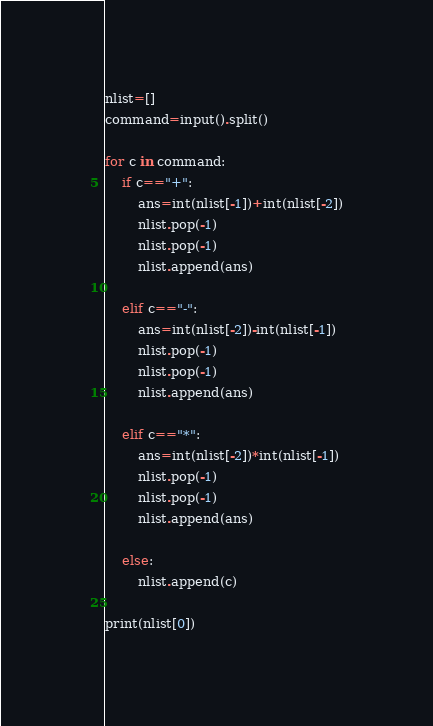<code> <loc_0><loc_0><loc_500><loc_500><_Python_>nlist=[]
command=input().split()

for c in command:
    if c=="+":
        ans=int(nlist[-1])+int(nlist[-2])
        nlist.pop(-1)
        nlist.pop(-1)
        nlist.append(ans)

    elif c=="-":
        ans=int(nlist[-2])-int(nlist[-1])
        nlist.pop(-1)
        nlist.pop(-1)
        nlist.append(ans)

    elif c=="*":
        ans=int(nlist[-2])*int(nlist[-1])
        nlist.pop(-1)
        nlist.pop(-1)
        nlist.append(ans)

    else:
        nlist.append(c)

print(nlist[0])
</code> 